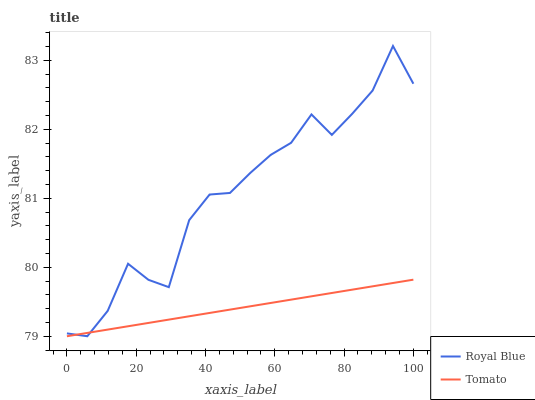Does Tomato have the minimum area under the curve?
Answer yes or no. Yes. Does Royal Blue have the maximum area under the curve?
Answer yes or no. Yes. Does Royal Blue have the minimum area under the curve?
Answer yes or no. No. Is Tomato the smoothest?
Answer yes or no. Yes. Is Royal Blue the roughest?
Answer yes or no. Yes. Is Royal Blue the smoothest?
Answer yes or no. No. Does Tomato have the lowest value?
Answer yes or no. Yes. Does Royal Blue have the highest value?
Answer yes or no. Yes. Does Tomato intersect Royal Blue?
Answer yes or no. Yes. Is Tomato less than Royal Blue?
Answer yes or no. No. Is Tomato greater than Royal Blue?
Answer yes or no. No. 